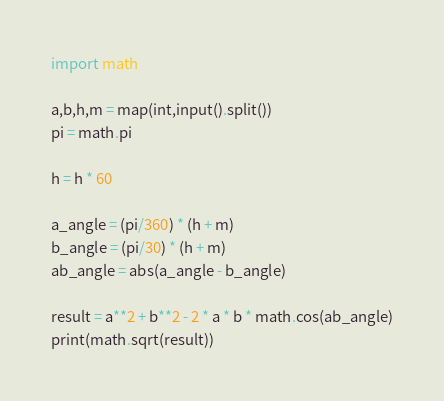<code> <loc_0><loc_0><loc_500><loc_500><_Python_>import math

a,b,h,m = map(int,input().split())
pi = math.pi

h = h * 60 

a_angle = (pi/360) * (h + m)
b_angle = (pi/30) * (h + m)
ab_angle = abs(a_angle - b_angle)

result = a**2 + b**2 - 2 * a * b * math.cos(ab_angle)
print(math.sqrt(result))
</code> 